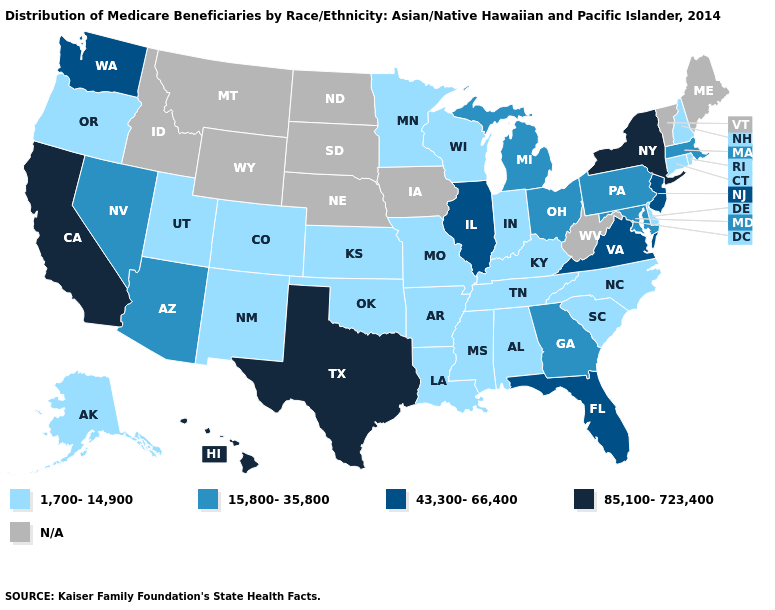What is the lowest value in the West?
Quick response, please. 1,700-14,900. Among the states that border North Carolina , which have the lowest value?
Concise answer only. South Carolina, Tennessee. What is the highest value in the South ?
Keep it brief. 85,100-723,400. What is the value of Indiana?
Short answer required. 1,700-14,900. Which states have the highest value in the USA?
Quick response, please. California, Hawaii, New York, Texas. Which states have the lowest value in the USA?
Be succinct. Alabama, Alaska, Arkansas, Colorado, Connecticut, Delaware, Indiana, Kansas, Kentucky, Louisiana, Minnesota, Mississippi, Missouri, New Hampshire, New Mexico, North Carolina, Oklahoma, Oregon, Rhode Island, South Carolina, Tennessee, Utah, Wisconsin. Which states have the lowest value in the USA?
Answer briefly. Alabama, Alaska, Arkansas, Colorado, Connecticut, Delaware, Indiana, Kansas, Kentucky, Louisiana, Minnesota, Mississippi, Missouri, New Hampshire, New Mexico, North Carolina, Oklahoma, Oregon, Rhode Island, South Carolina, Tennessee, Utah, Wisconsin. What is the value of South Dakota?
Write a very short answer. N/A. What is the highest value in the West ?
Write a very short answer. 85,100-723,400. Is the legend a continuous bar?
Write a very short answer. No. What is the highest value in the West ?
Give a very brief answer. 85,100-723,400. Name the states that have a value in the range 1,700-14,900?
Write a very short answer. Alabama, Alaska, Arkansas, Colorado, Connecticut, Delaware, Indiana, Kansas, Kentucky, Louisiana, Minnesota, Mississippi, Missouri, New Hampshire, New Mexico, North Carolina, Oklahoma, Oregon, Rhode Island, South Carolina, Tennessee, Utah, Wisconsin. Does Connecticut have the lowest value in the Northeast?
Give a very brief answer. Yes. Does the map have missing data?
Write a very short answer. Yes. 